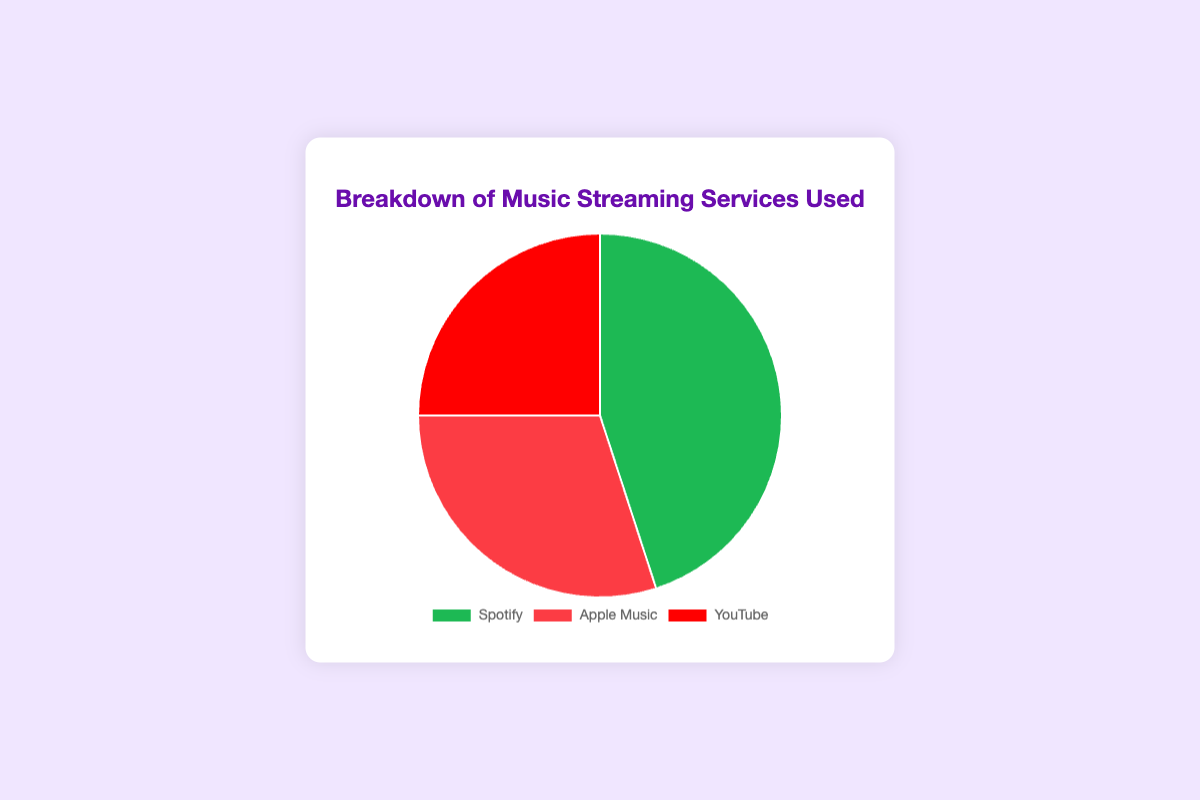Which music streaming service is used the most? By looking at the figure, we see that Spotify has the highest percentage, with 45% of the total usage.
Answer: Spotify Which service is used less, YouTube or Apple Music? According to the pie chart, YouTube accounts for 25% while Apple Music accounts for 30%. Since 25% is less than 30%, YouTube is used less.
Answer: YouTube What is the total percentage of users that use either Spotify or Apple Music? Spotify has 45% and Apple Music has 30%. Adding these together, 45% + 30% = 75%.
Answer: 75% How much more popular is Spotify compared to YouTube? The percentage for Spotify is 45%, whereas for YouTube it is 25%. The difference can be calculated as 45% - 25% = 20%.
Answer: 20% If you combine the percentages of YouTube and Apple Music, how do they compare to Spotify? Adding YouTube's 25% and Apple Music's 30%, we get 25% + 30% = 55%. Comparing this to Spotify's 45%, 55% is greater than 45%.
Answer: 55% is greater than 45% What percentage of users do not use Spotify? Since 45% of users use Spotify, the rest do not use Spotify, which is 100% - 45% = 55%.
Answer: 55% Which two services together roughly make up the largest share of users? Combining Spotify and Apple Music gives us 45% + 30% = 75%, whereas combining Spotify and YouTube gives us 45% + 25% = 70%, and combining Apple Music and YouTube gives us 30% + 25% = 55%. Therefore, Spotify and Apple Music together make up the largest share, 75%.
Answer: Spotify and Apple Music Assuming the total number of users is 1,000, how many users are using YouTube? If YouTube is used by 25% of users out of 1,000, the number of users is 25% of 1,000, which is 0.25 * 1,000 = 250.
Answer: 250 What is the difference in percentage points between the most popular and the least popular service? The most popular is Spotify with 45%, and the least popular is YouTube with 25%. The difference is 45% - 25% = 20 percentage points.
Answer: 20 percentage points 